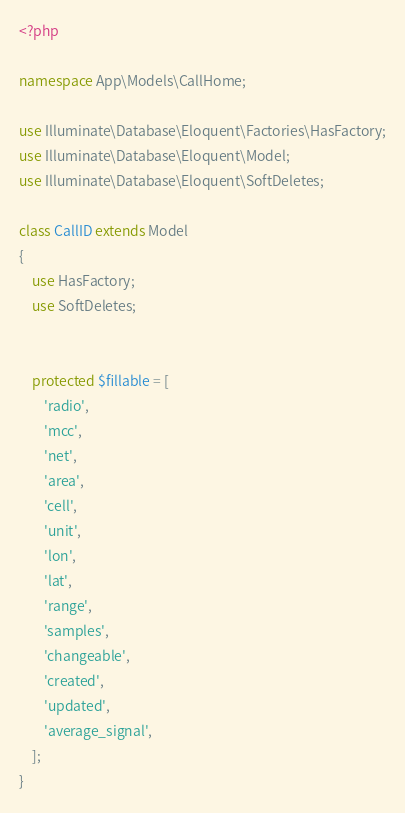<code> <loc_0><loc_0><loc_500><loc_500><_PHP_><?php

namespace App\Models\CallHome;

use Illuminate\Database\Eloquent\Factories\HasFactory;
use Illuminate\Database\Eloquent\Model;
use Illuminate\Database\Eloquent\SoftDeletes;

class CallID extends Model
{
    use HasFactory;
    use SoftDeletes;


    protected $fillable = [
        'radio',
        'mcc',
        'net',
        'area',
        'cell',
        'unit',
        'lon',
        'lat',
        'range',
        'samples',
        'changeable',
        'created',
        'updated',
        'average_signal',
    ];
}
</code> 